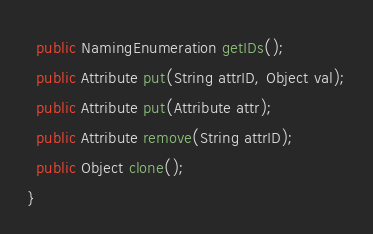Convert code to text. <code><loc_0><loc_0><loc_500><loc_500><_Java_>  public NamingEnumeration getIDs();
  public Attribute put(String attrID, Object val);
  public Attribute put(Attribute attr);
  public Attribute remove(String attrID);
  public Object clone();
}

</code> 